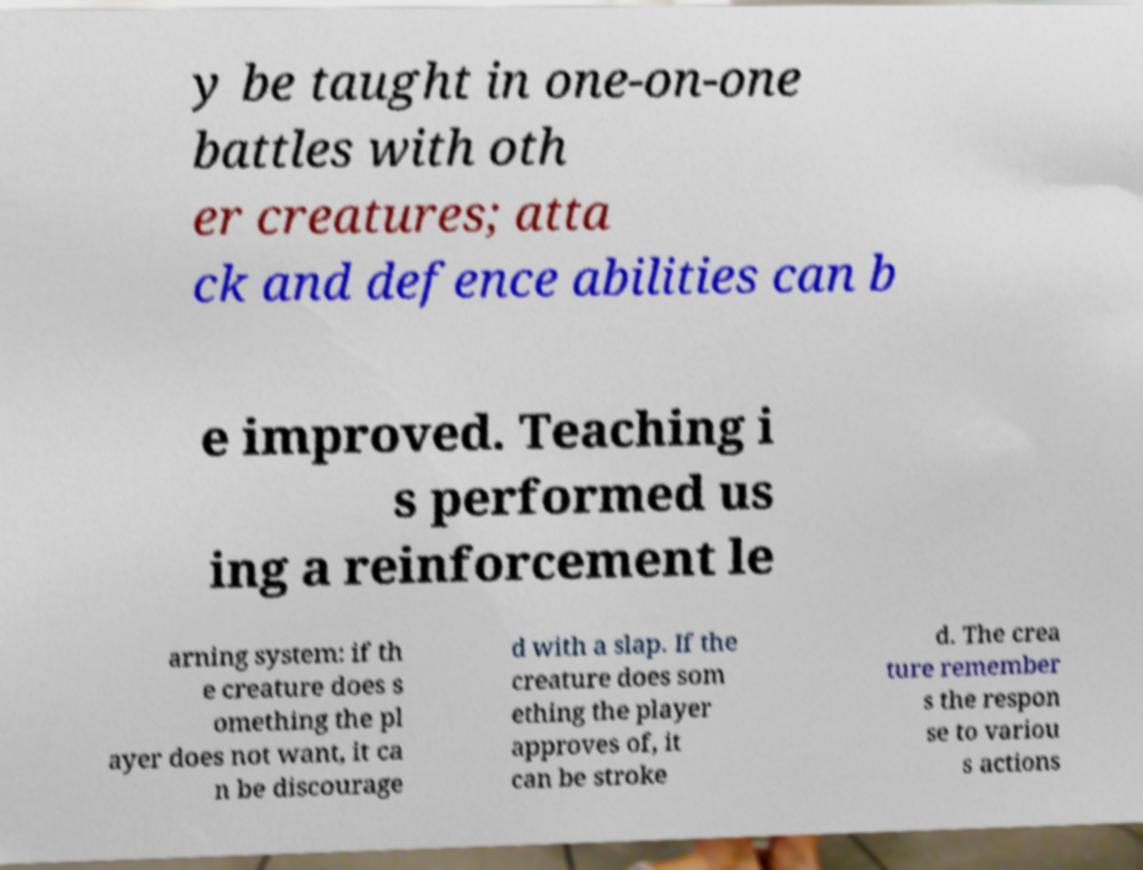What messages or text are displayed in this image? I need them in a readable, typed format. y be taught in one-on-one battles with oth er creatures; atta ck and defence abilities can b e improved. Teaching i s performed us ing a reinforcement le arning system: if th e creature does s omething the pl ayer does not want, it ca n be discourage d with a slap. If the creature does som ething the player approves of, it can be stroke d. The crea ture remember s the respon se to variou s actions 